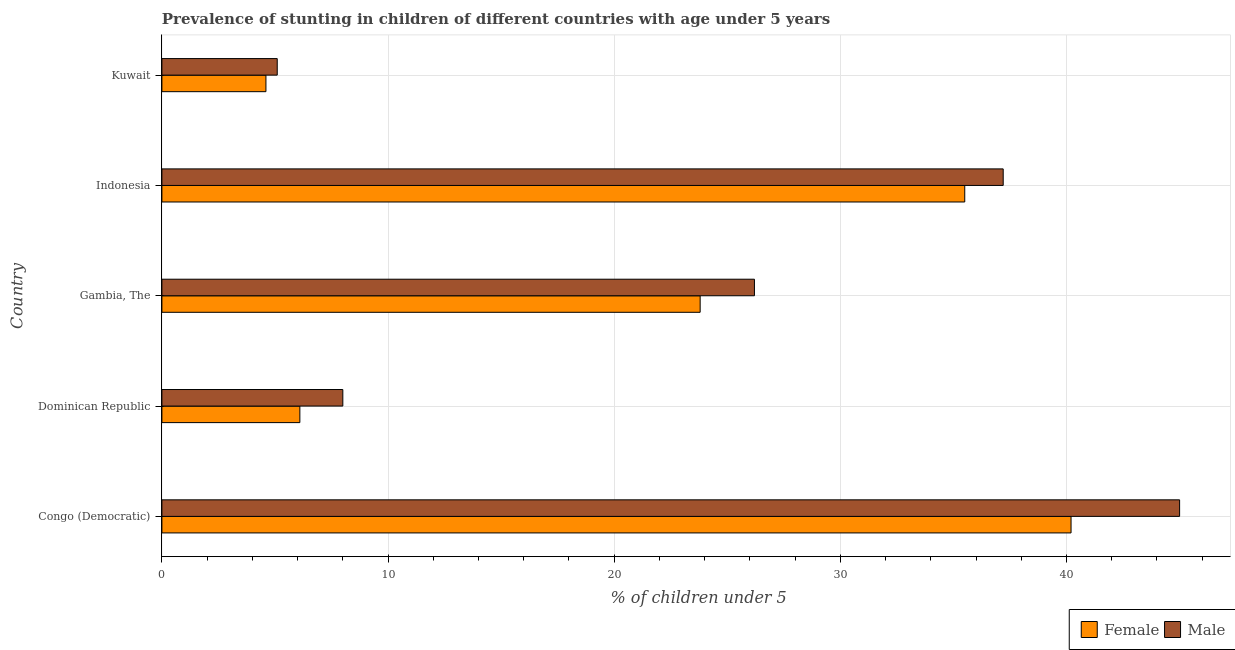How many different coloured bars are there?
Give a very brief answer. 2. How many groups of bars are there?
Provide a succinct answer. 5. How many bars are there on the 5th tick from the top?
Your answer should be very brief. 2. How many bars are there on the 4th tick from the bottom?
Offer a terse response. 2. What is the label of the 1st group of bars from the top?
Offer a terse response. Kuwait. What is the percentage of stunted male children in Kuwait?
Your response must be concise. 5.1. Across all countries, what is the minimum percentage of stunted male children?
Offer a terse response. 5.1. In which country was the percentage of stunted male children maximum?
Offer a very short reply. Congo (Democratic). In which country was the percentage of stunted male children minimum?
Your answer should be compact. Kuwait. What is the total percentage of stunted female children in the graph?
Keep it short and to the point. 110.2. What is the difference between the percentage of stunted male children in Gambia, The and that in Kuwait?
Your response must be concise. 21.1. What is the difference between the percentage of stunted female children in Congo (Democratic) and the percentage of stunted male children in Indonesia?
Offer a very short reply. 3. What is the average percentage of stunted female children per country?
Your response must be concise. 22.04. What is the ratio of the percentage of stunted male children in Congo (Democratic) to that in Gambia, The?
Your answer should be very brief. 1.72. Is the percentage of stunted male children in Indonesia less than that in Kuwait?
Your answer should be very brief. No. Is the difference between the percentage of stunted female children in Congo (Democratic) and Indonesia greater than the difference between the percentage of stunted male children in Congo (Democratic) and Indonesia?
Keep it short and to the point. No. What is the difference between the highest and the second highest percentage of stunted male children?
Offer a terse response. 7.8. What is the difference between the highest and the lowest percentage of stunted male children?
Offer a very short reply. 39.9. In how many countries, is the percentage of stunted male children greater than the average percentage of stunted male children taken over all countries?
Make the answer very short. 3. Are all the bars in the graph horizontal?
Keep it short and to the point. Yes. Does the graph contain any zero values?
Offer a terse response. No. Where does the legend appear in the graph?
Keep it short and to the point. Bottom right. How many legend labels are there?
Your answer should be very brief. 2. How are the legend labels stacked?
Ensure brevity in your answer.  Horizontal. What is the title of the graph?
Your answer should be compact. Prevalence of stunting in children of different countries with age under 5 years. What is the label or title of the X-axis?
Offer a terse response.  % of children under 5. What is the label or title of the Y-axis?
Provide a short and direct response. Country. What is the  % of children under 5 in Female in Congo (Democratic)?
Ensure brevity in your answer.  40.2. What is the  % of children under 5 of Male in Congo (Democratic)?
Provide a short and direct response. 45. What is the  % of children under 5 of Female in Dominican Republic?
Provide a succinct answer. 6.1. What is the  % of children under 5 of Female in Gambia, The?
Keep it short and to the point. 23.8. What is the  % of children under 5 in Male in Gambia, The?
Your answer should be compact. 26.2. What is the  % of children under 5 of Female in Indonesia?
Ensure brevity in your answer.  35.5. What is the  % of children under 5 in Male in Indonesia?
Your response must be concise. 37.2. What is the  % of children under 5 in Female in Kuwait?
Offer a very short reply. 4.6. What is the  % of children under 5 of Male in Kuwait?
Provide a short and direct response. 5.1. Across all countries, what is the maximum  % of children under 5 in Female?
Ensure brevity in your answer.  40.2. Across all countries, what is the maximum  % of children under 5 in Male?
Keep it short and to the point. 45. Across all countries, what is the minimum  % of children under 5 of Female?
Offer a terse response. 4.6. Across all countries, what is the minimum  % of children under 5 of Male?
Ensure brevity in your answer.  5.1. What is the total  % of children under 5 in Female in the graph?
Make the answer very short. 110.2. What is the total  % of children under 5 in Male in the graph?
Your response must be concise. 121.5. What is the difference between the  % of children under 5 of Female in Congo (Democratic) and that in Dominican Republic?
Offer a terse response. 34.1. What is the difference between the  % of children under 5 in Female in Congo (Democratic) and that in Gambia, The?
Keep it short and to the point. 16.4. What is the difference between the  % of children under 5 in Female in Congo (Democratic) and that in Kuwait?
Keep it short and to the point. 35.6. What is the difference between the  % of children under 5 of Male in Congo (Democratic) and that in Kuwait?
Your answer should be very brief. 39.9. What is the difference between the  % of children under 5 of Female in Dominican Republic and that in Gambia, The?
Make the answer very short. -17.7. What is the difference between the  % of children under 5 of Male in Dominican Republic and that in Gambia, The?
Offer a terse response. -18.2. What is the difference between the  % of children under 5 in Female in Dominican Republic and that in Indonesia?
Your answer should be compact. -29.4. What is the difference between the  % of children under 5 in Male in Dominican Republic and that in Indonesia?
Make the answer very short. -29.2. What is the difference between the  % of children under 5 of Female in Dominican Republic and that in Kuwait?
Give a very brief answer. 1.5. What is the difference between the  % of children under 5 of Male in Gambia, The and that in Kuwait?
Keep it short and to the point. 21.1. What is the difference between the  % of children under 5 in Female in Indonesia and that in Kuwait?
Provide a short and direct response. 30.9. What is the difference between the  % of children under 5 in Male in Indonesia and that in Kuwait?
Ensure brevity in your answer.  32.1. What is the difference between the  % of children under 5 of Female in Congo (Democratic) and the  % of children under 5 of Male in Dominican Republic?
Your answer should be very brief. 32.2. What is the difference between the  % of children under 5 in Female in Congo (Democratic) and the  % of children under 5 in Male in Gambia, The?
Ensure brevity in your answer.  14. What is the difference between the  % of children under 5 of Female in Congo (Democratic) and the  % of children under 5 of Male in Indonesia?
Provide a succinct answer. 3. What is the difference between the  % of children under 5 in Female in Congo (Democratic) and the  % of children under 5 in Male in Kuwait?
Your answer should be very brief. 35.1. What is the difference between the  % of children under 5 in Female in Dominican Republic and the  % of children under 5 in Male in Gambia, The?
Offer a very short reply. -20.1. What is the difference between the  % of children under 5 of Female in Dominican Republic and the  % of children under 5 of Male in Indonesia?
Your response must be concise. -31.1. What is the difference between the  % of children under 5 in Female in Dominican Republic and the  % of children under 5 in Male in Kuwait?
Keep it short and to the point. 1. What is the difference between the  % of children under 5 of Female in Gambia, The and the  % of children under 5 of Male in Kuwait?
Keep it short and to the point. 18.7. What is the difference between the  % of children under 5 in Female in Indonesia and the  % of children under 5 in Male in Kuwait?
Provide a succinct answer. 30.4. What is the average  % of children under 5 in Female per country?
Offer a terse response. 22.04. What is the average  % of children under 5 in Male per country?
Your answer should be compact. 24.3. What is the difference between the  % of children under 5 of Female and  % of children under 5 of Male in Dominican Republic?
Your response must be concise. -1.9. What is the difference between the  % of children under 5 in Female and  % of children under 5 in Male in Indonesia?
Offer a very short reply. -1.7. What is the difference between the  % of children under 5 of Female and  % of children under 5 of Male in Kuwait?
Offer a very short reply. -0.5. What is the ratio of the  % of children under 5 of Female in Congo (Democratic) to that in Dominican Republic?
Offer a terse response. 6.59. What is the ratio of the  % of children under 5 of Male in Congo (Democratic) to that in Dominican Republic?
Your answer should be very brief. 5.62. What is the ratio of the  % of children under 5 of Female in Congo (Democratic) to that in Gambia, The?
Offer a terse response. 1.69. What is the ratio of the  % of children under 5 of Male in Congo (Democratic) to that in Gambia, The?
Ensure brevity in your answer.  1.72. What is the ratio of the  % of children under 5 of Female in Congo (Democratic) to that in Indonesia?
Give a very brief answer. 1.13. What is the ratio of the  % of children under 5 of Male in Congo (Democratic) to that in Indonesia?
Your answer should be very brief. 1.21. What is the ratio of the  % of children under 5 of Female in Congo (Democratic) to that in Kuwait?
Offer a very short reply. 8.74. What is the ratio of the  % of children under 5 of Male in Congo (Democratic) to that in Kuwait?
Offer a very short reply. 8.82. What is the ratio of the  % of children under 5 of Female in Dominican Republic to that in Gambia, The?
Your response must be concise. 0.26. What is the ratio of the  % of children under 5 of Male in Dominican Republic to that in Gambia, The?
Provide a short and direct response. 0.31. What is the ratio of the  % of children under 5 in Female in Dominican Republic to that in Indonesia?
Provide a succinct answer. 0.17. What is the ratio of the  % of children under 5 in Male in Dominican Republic to that in Indonesia?
Your answer should be very brief. 0.22. What is the ratio of the  % of children under 5 in Female in Dominican Republic to that in Kuwait?
Keep it short and to the point. 1.33. What is the ratio of the  % of children under 5 in Male in Dominican Republic to that in Kuwait?
Ensure brevity in your answer.  1.57. What is the ratio of the  % of children under 5 of Female in Gambia, The to that in Indonesia?
Offer a terse response. 0.67. What is the ratio of the  % of children under 5 of Male in Gambia, The to that in Indonesia?
Your answer should be compact. 0.7. What is the ratio of the  % of children under 5 of Female in Gambia, The to that in Kuwait?
Provide a short and direct response. 5.17. What is the ratio of the  % of children under 5 of Male in Gambia, The to that in Kuwait?
Offer a very short reply. 5.14. What is the ratio of the  % of children under 5 of Female in Indonesia to that in Kuwait?
Make the answer very short. 7.72. What is the ratio of the  % of children under 5 in Male in Indonesia to that in Kuwait?
Your answer should be compact. 7.29. What is the difference between the highest and the second highest  % of children under 5 of Female?
Provide a short and direct response. 4.7. What is the difference between the highest and the second highest  % of children under 5 in Male?
Ensure brevity in your answer.  7.8. What is the difference between the highest and the lowest  % of children under 5 in Female?
Keep it short and to the point. 35.6. What is the difference between the highest and the lowest  % of children under 5 in Male?
Make the answer very short. 39.9. 